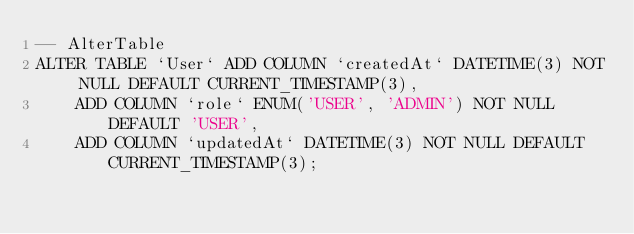Convert code to text. <code><loc_0><loc_0><loc_500><loc_500><_SQL_>-- AlterTable
ALTER TABLE `User` ADD COLUMN `createdAt` DATETIME(3) NOT NULL DEFAULT CURRENT_TIMESTAMP(3),
    ADD COLUMN `role` ENUM('USER', 'ADMIN') NOT NULL DEFAULT 'USER',
    ADD COLUMN `updatedAt` DATETIME(3) NOT NULL DEFAULT CURRENT_TIMESTAMP(3);
</code> 